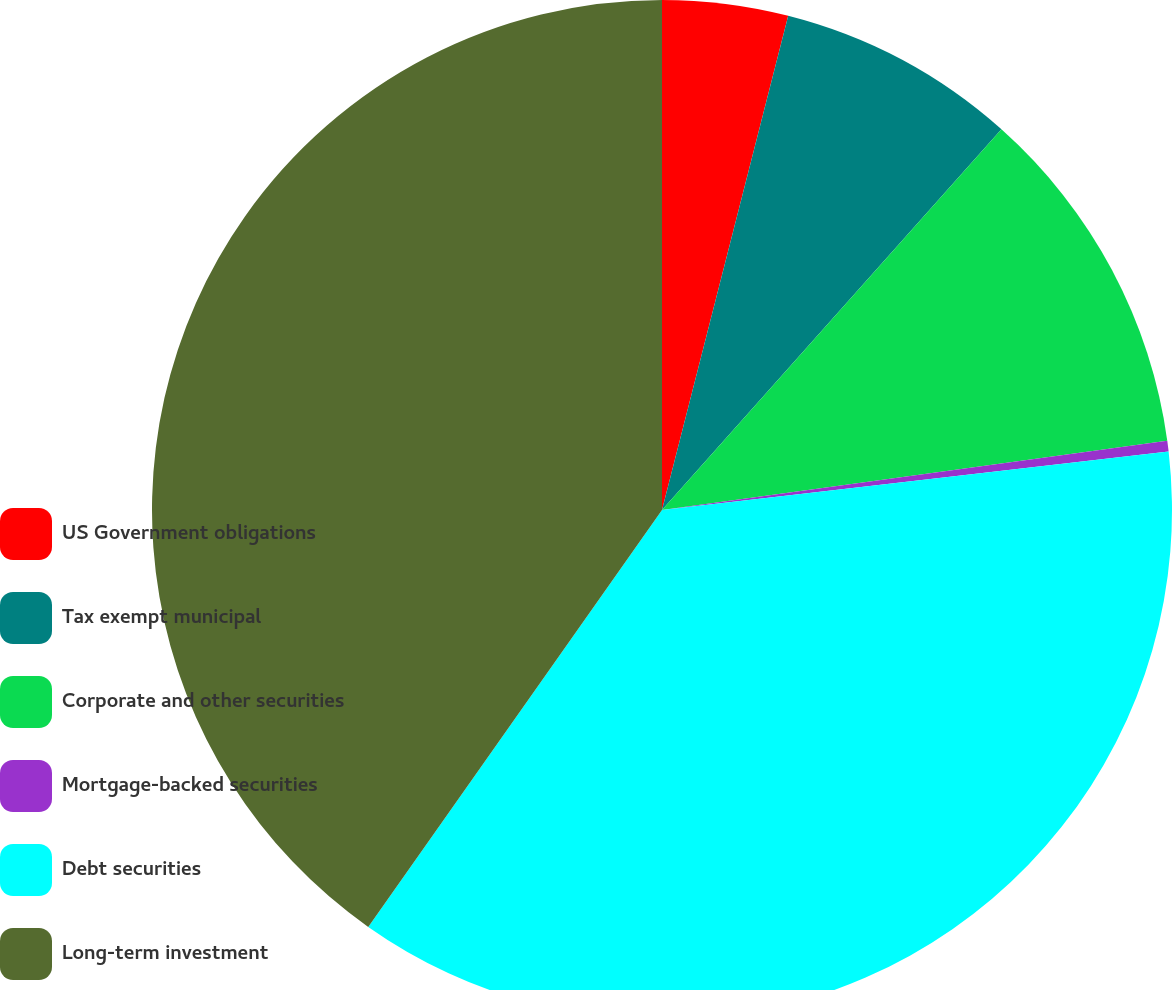<chart> <loc_0><loc_0><loc_500><loc_500><pie_chart><fcel>US Government obligations<fcel>Tax exempt municipal<fcel>Corporate and other securities<fcel>Mortgage-backed securities<fcel>Debt securities<fcel>Long-term investment<nl><fcel>3.98%<fcel>7.61%<fcel>11.24%<fcel>0.34%<fcel>36.6%<fcel>40.23%<nl></chart> 